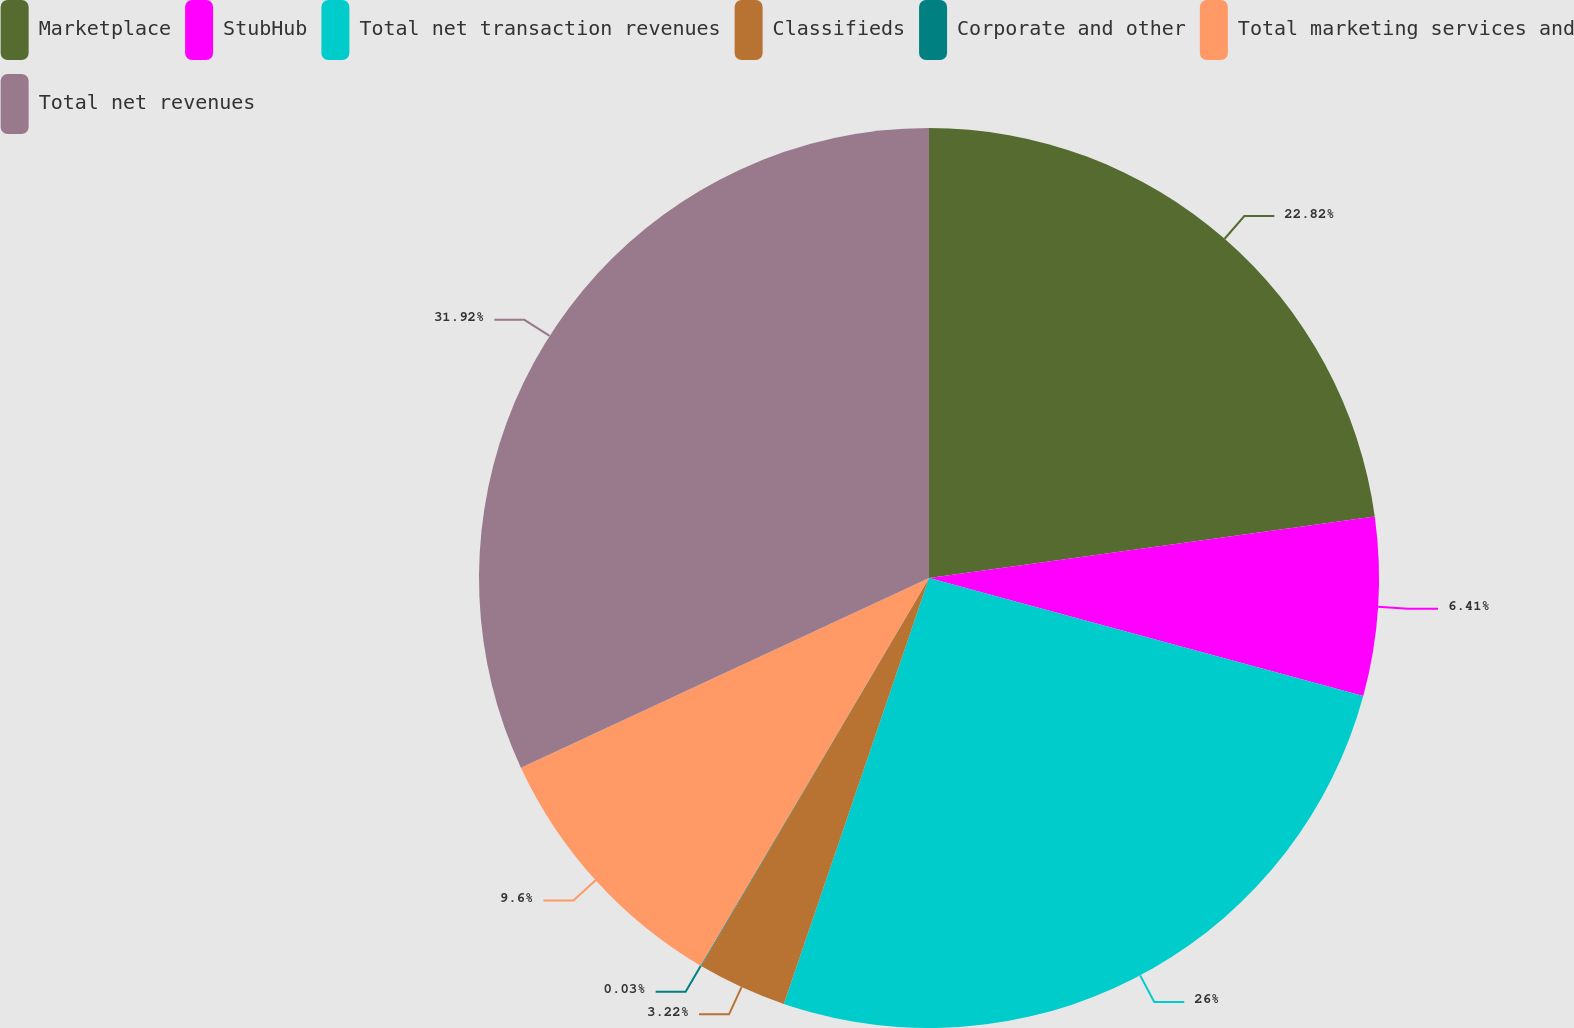Convert chart. <chart><loc_0><loc_0><loc_500><loc_500><pie_chart><fcel>Marketplace<fcel>StubHub<fcel>Total net transaction revenues<fcel>Classifieds<fcel>Corporate and other<fcel>Total marketing services and<fcel>Total net revenues<nl><fcel>22.82%<fcel>6.41%<fcel>26.01%<fcel>3.22%<fcel>0.03%<fcel>9.6%<fcel>31.93%<nl></chart> 